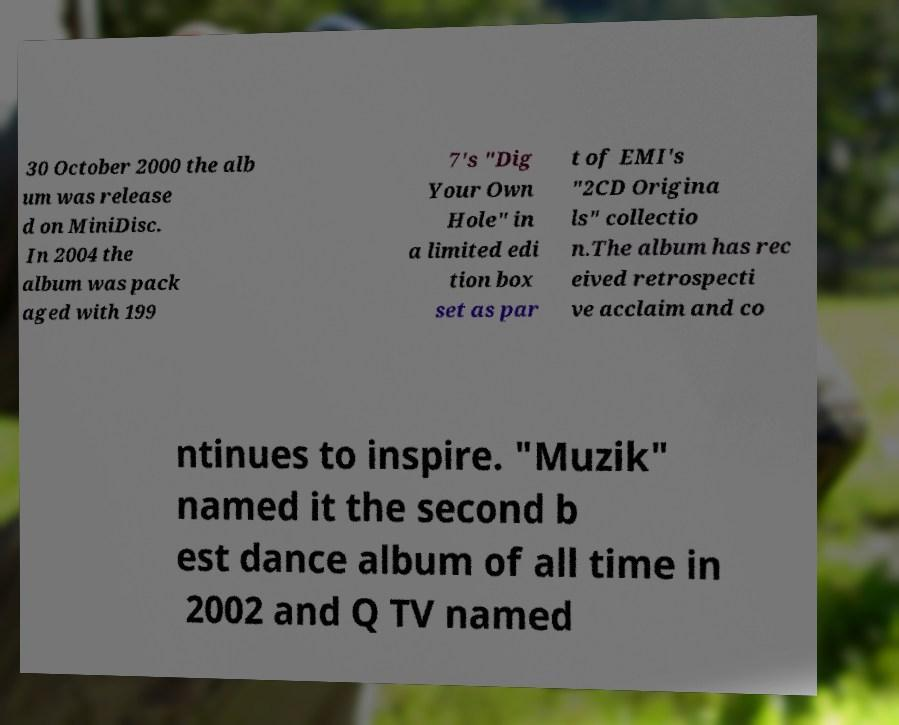Please identify and transcribe the text found in this image. 30 October 2000 the alb um was release d on MiniDisc. In 2004 the album was pack aged with 199 7's "Dig Your Own Hole" in a limited edi tion box set as par t of EMI's "2CD Origina ls" collectio n.The album has rec eived retrospecti ve acclaim and co ntinues to inspire. "Muzik" named it the second b est dance album of all time in 2002 and Q TV named 